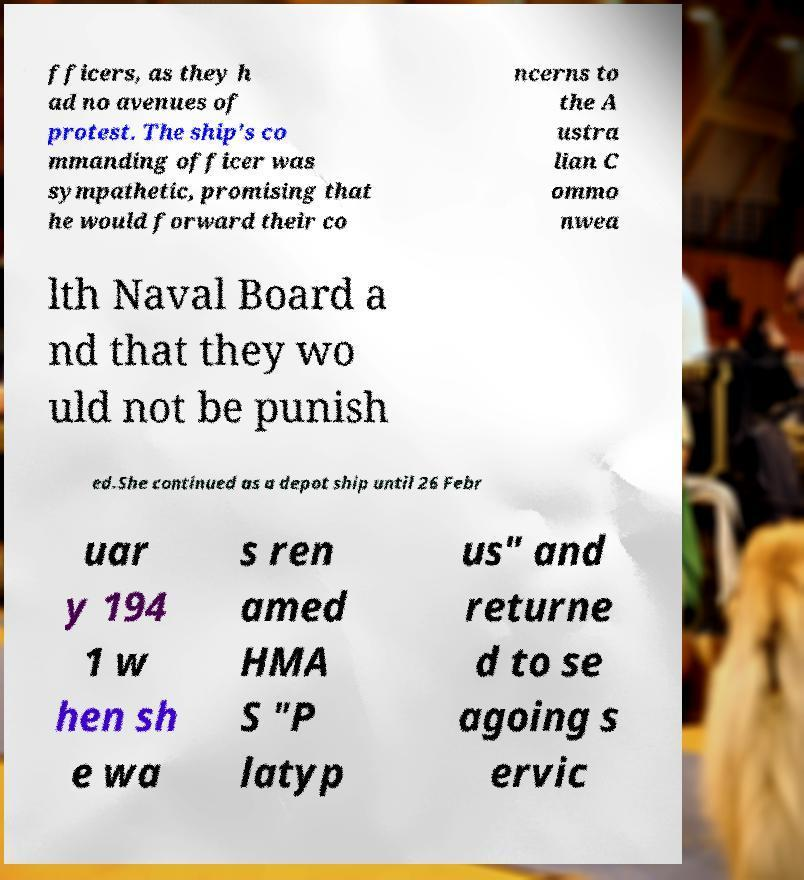There's text embedded in this image that I need extracted. Can you transcribe it verbatim? fficers, as they h ad no avenues of protest. The ship's co mmanding officer was sympathetic, promising that he would forward their co ncerns to the A ustra lian C ommo nwea lth Naval Board a nd that they wo uld not be punish ed.She continued as a depot ship until 26 Febr uar y 194 1 w hen sh e wa s ren amed HMA S "P latyp us" and returne d to se agoing s ervic 